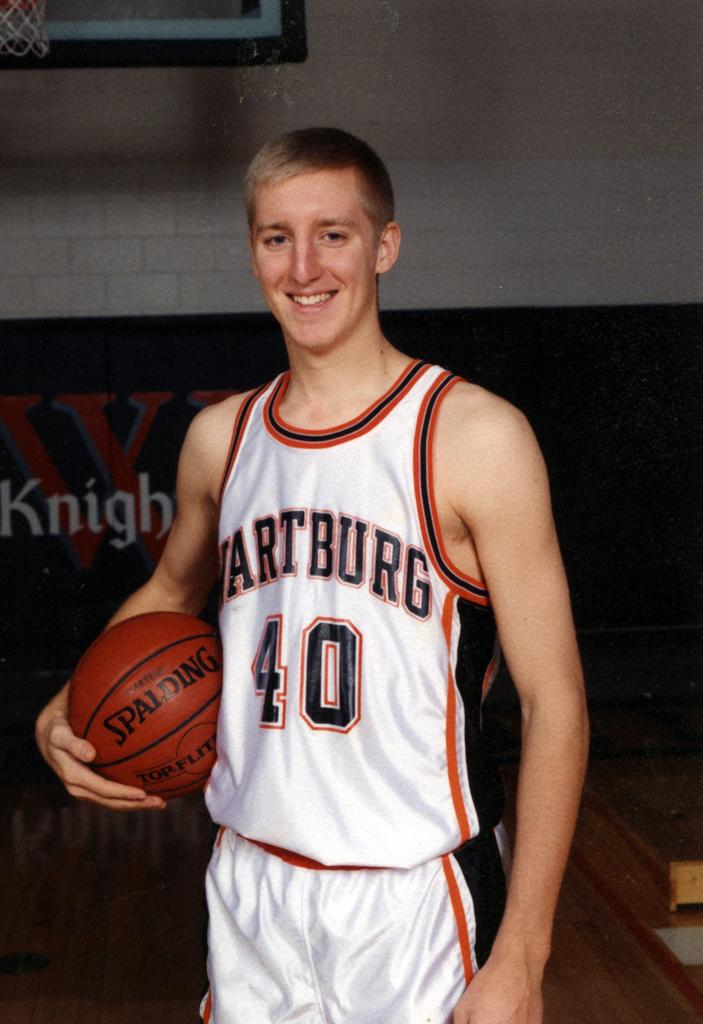Provide a one-sentence caption for the provided image. A basketball player wearing the jersey number 40 holds a Spalding basketball. 